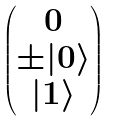<formula> <loc_0><loc_0><loc_500><loc_500>\begin{pmatrix} 0 \\ \pm | 0 \rangle \\ | 1 \rangle \\ \end{pmatrix}</formula> 